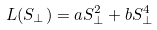<formula> <loc_0><loc_0><loc_500><loc_500>L ( S _ { \perp } ) = a S _ { \perp } ^ { 2 } + b S _ { \perp } ^ { 4 }</formula> 